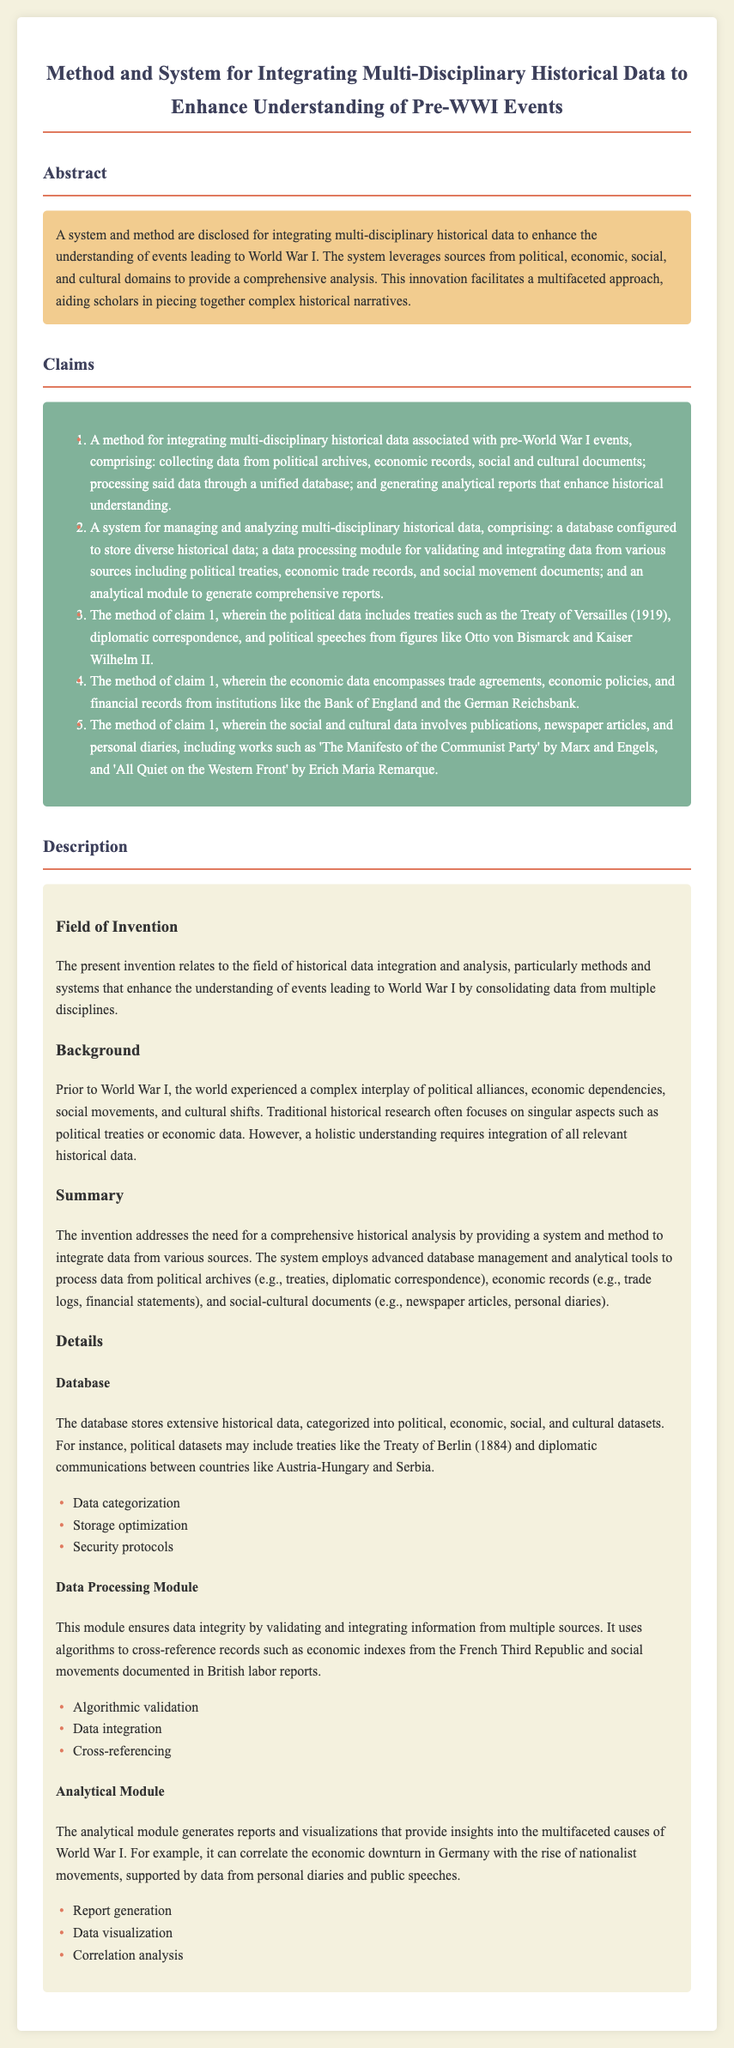What is the title of the patent application? The title of the patent application is found in the header section of the document.
Answer: Method and System for Integrating Multi-Disciplinary Historical Data to Enhance Understanding of Pre-WWI Events What is one type of data collected for analysis according to the claims? The claims outline various types of data that can be collected, including political archives.
Answer: Political archives What does the analytical module generate? The document specifies what the analytical module produces for insights regarding historical events.
Answer: Reports and visualizations Who are the authors of 'The Manifesto of the Communist Party'? The method specifically mentions works included in the social and cultural data category.
Answer: Marx and Engels What kind of data does the database store? The description explains the types of datasets stored in the database.
Answer: Political, economic, social, and cultural datasets What is a function of the data processing module? The description details the responsibilities of the data processing module within the system.
Answer: Validating and integrating data Which treaty is specifically mentioned in the description of political data? The description under claims provides examples of political data types, including treaties.
Answer: Treaty of Versailles How does the system enhance historical understanding? The abstract states the main purpose of the system outlined in the document.
Answer: Integrating multi-disciplinary historical data 